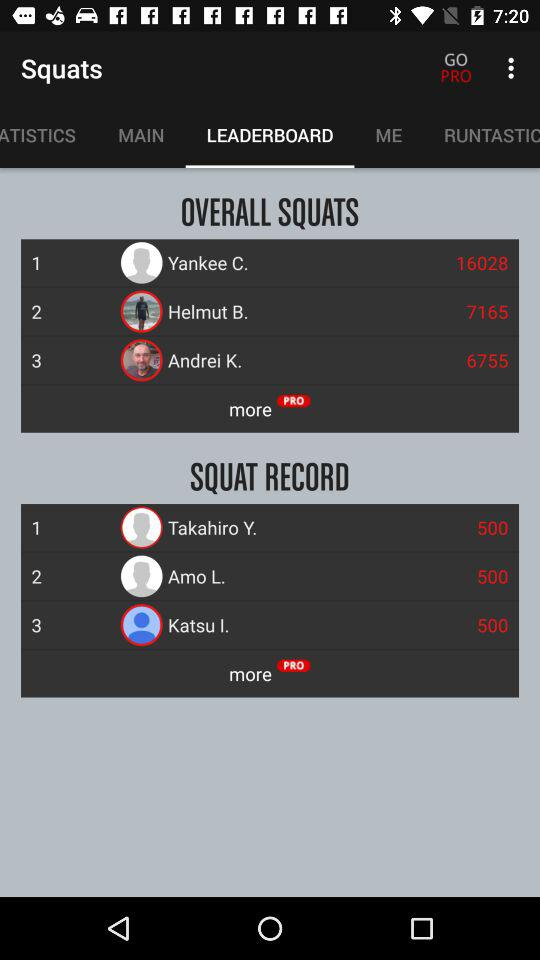What is Overall Squats?
When the provided information is insufficient, respond with <no answer>. <no answer> 